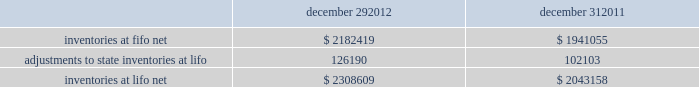In june 2011 , the fasb issued asu no .
2011-05 201ccomprehensive income 2013 presentation of comprehensive income . 201d asu 2011-05 requires comprehensive income , the components of net income , and the components of other comprehensive income either in a single continuous statement of comprehensive income or in two separate but consecutive statements .
In both choices , an entity is required to present each component of net income along with total net income , each component of other comprehensive income along with a total for other comprehensive income , and a total amount for comprehensive income .
This update eliminates the option to present the components of other comprehensive income as part of the statement of changes in stockholders' equity .
The amendments in this update do not change the items that must be reported in other comprehensive income or when an item of other comprehensive income must be reclassified to net income .
The amendments in this update should be applied retrospectively and is effective for interim and annual reporting periods beginning after december 15 , 2011 .
The company adopted this guidance in the first quarter of 2012 .
The adoption of asu 2011-05 is for presentation purposes only and had no material impact on the company 2019s consolidated financial statements .
Inventories , net : merchandise inventory the company used the lifo method of accounting for approximately 95% ( 95 % ) of inventories at both december 29 , 2012 and december 31 , 2011 .
Under lifo , the company 2019s cost of sales reflects the costs of the most recently purchased inventories , while the inventory carrying balance represents the costs for inventories purchased in fiscal 2012 and prior years .
The company recorded a reduction to cost of sales of $ 24087 and $ 29554 in fiscal 2012 and fiscal 2010 , respectively .
As a result of utilizing lifo , the company recorded an increase to cost of sales of $ 24708 for fiscal 2011 , due to an increase in supply chain costs and inflationary pressures affecting certain product categories .
The company 2019s overall costs to acquire inventory for the same or similar products have generally decreased historically as the company has been able to leverage its continued growth , execution of merchandise strategies and realization of supply chain efficiencies .
Product cores the remaining inventories are comprised of product cores , the non-consumable portion of certain parts and batteries , which are valued under the first-in , first-out ( "fifo" ) method .
Product cores are included as part of the company's merchandise costs and are either passed on to the customer or returned to the vendor .
Because product cores are not subject to frequent cost changes like the company's other merchandise inventory , there is no material difference when applying either the lifo or fifo valuation method .
Inventory overhead costs purchasing and warehousing costs included in inventory at december 29 , 2012 and december 31 , 2011 , were $ 134258 and $ 126840 , respectively .
Inventory balance and inventory reserves inventory balances at the end of fiscal 2012 and 2011 were as follows : december 29 , december 31 .
Inventory quantities are tracked through a perpetual inventory system .
The company completes physical inventories and other targeted inventory counts in its store locations to ensure the accuracy of the perpetual inventory quantities of both merchandise and core inventory in these locations .
In its distribution centers and pdq aes , the company uses a cycle counting program to ensure the accuracy of the perpetual inventory quantities of both merchandise and product core inventory .
Reserves advance auto parts , inc .
And subsidiaries notes to the consolidated financial statements december 29 , 2012 , december 31 , 2011 and january 1 , 2011 ( in thousands , except per share data ) .
What is the percentage change in inventories at lifo net during 2012? 
Computations: ((2308609 - 2043158) / 2043158)
Answer: 0.12992. 